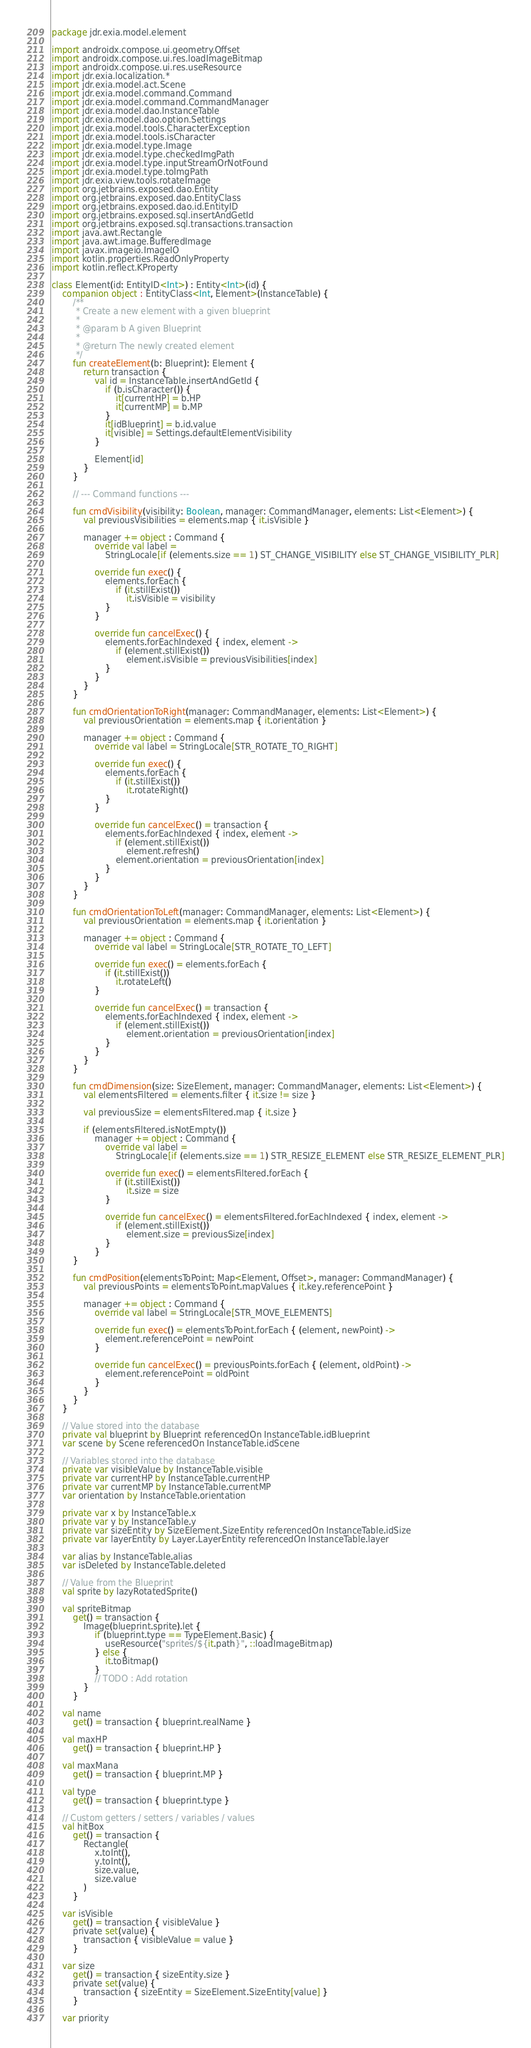<code> <loc_0><loc_0><loc_500><loc_500><_Kotlin_>package jdr.exia.model.element

import androidx.compose.ui.geometry.Offset
import androidx.compose.ui.res.loadImageBitmap
import androidx.compose.ui.res.useResource
import jdr.exia.localization.*
import jdr.exia.model.act.Scene
import jdr.exia.model.command.Command
import jdr.exia.model.command.CommandManager
import jdr.exia.model.dao.InstanceTable
import jdr.exia.model.dao.option.Settings
import jdr.exia.model.tools.CharacterException
import jdr.exia.model.tools.isCharacter
import jdr.exia.model.type.Image
import jdr.exia.model.type.checkedImgPath
import jdr.exia.model.type.inputStreamOrNotFound
import jdr.exia.model.type.toImgPath
import jdr.exia.view.tools.rotateImage
import org.jetbrains.exposed.dao.Entity
import org.jetbrains.exposed.dao.EntityClass
import org.jetbrains.exposed.dao.id.EntityID
import org.jetbrains.exposed.sql.insertAndGetId
import org.jetbrains.exposed.sql.transactions.transaction
import java.awt.Rectangle
import java.awt.image.BufferedImage
import javax.imageio.ImageIO
import kotlin.properties.ReadOnlyProperty
import kotlin.reflect.KProperty

class Element(id: EntityID<Int>) : Entity<Int>(id) {
    companion object : EntityClass<Int, Element>(InstanceTable) {
        /**
         * Create a new element with a given blueprint
         *
         * @param b A given Blueprint
         *
         * @return The newly created element
         */
        fun createElement(b: Blueprint): Element {
            return transaction {
                val id = InstanceTable.insertAndGetId {
                    if (b.isCharacter()) {
                        it[currentHP] = b.HP
                        it[currentMP] = b.MP
                    }
                    it[idBlueprint] = b.id.value
                    it[visible] = Settings.defaultElementVisibility
                }

                Element[id]
            }
        }

        // --- Command functions ---

        fun cmdVisibility(visibility: Boolean, manager: CommandManager, elements: List<Element>) {
            val previousVisibilities = elements.map { it.isVisible }

            manager += object : Command {
                override val label =
                    StringLocale[if (elements.size == 1) ST_CHANGE_VISIBILITY else ST_CHANGE_VISIBILITY_PLR]

                override fun exec() {
                    elements.forEach {
                        if (it.stillExist())
                            it.isVisible = visibility
                    }
                }

                override fun cancelExec() {
                    elements.forEachIndexed { index, element ->
                        if (element.stillExist())
                            element.isVisible = previousVisibilities[index]
                    }
                }
            }
        }

        fun cmdOrientationToRight(manager: CommandManager, elements: List<Element>) {
            val previousOrientation = elements.map { it.orientation }

            manager += object : Command {
                override val label = StringLocale[STR_ROTATE_TO_RIGHT]

                override fun exec() {
                    elements.forEach {
                        if (it.stillExist())
                            it.rotateRight()
                    }
                }

                override fun cancelExec() = transaction {
                    elements.forEachIndexed { index, element ->
                        if (element.stillExist())
                            element.refresh()
                        element.orientation = previousOrientation[index]
                    }
                }
            }
        }

        fun cmdOrientationToLeft(manager: CommandManager, elements: List<Element>) {
            val previousOrientation = elements.map { it.orientation }

            manager += object : Command {
                override val label = StringLocale[STR_ROTATE_TO_LEFT]

                override fun exec() = elements.forEach {
                    if (it.stillExist())
                        it.rotateLeft()
                }

                override fun cancelExec() = transaction {
                    elements.forEachIndexed { index, element ->
                        if (element.stillExist())
                            element.orientation = previousOrientation[index]
                    }
                }
            }
        }

        fun cmdDimension(size: SizeElement, manager: CommandManager, elements: List<Element>) {
            val elementsFiltered = elements.filter { it.size != size }

            val previousSize = elementsFiltered.map { it.size }

            if (elementsFiltered.isNotEmpty())
                manager += object : Command {
                    override val label =
                        StringLocale[if (elements.size == 1) STR_RESIZE_ELEMENT else STR_RESIZE_ELEMENT_PLR]

                    override fun exec() = elementsFiltered.forEach {
                        if (it.stillExist())
                            it.size = size
                    }

                    override fun cancelExec() = elementsFiltered.forEachIndexed { index, element ->
                        if (element.stillExist())
                            element.size = previousSize[index]
                    }
                }
        }

        fun cmdPosition(elementsToPoint: Map<Element, Offset>, manager: CommandManager) {
            val previousPoints = elementsToPoint.mapValues { it.key.referencePoint }

            manager += object : Command {
                override val label = StringLocale[STR_MOVE_ELEMENTS]

                override fun exec() = elementsToPoint.forEach { (element, newPoint) ->
                    element.referencePoint = newPoint
                }

                override fun cancelExec() = previousPoints.forEach { (element, oldPoint) ->
                    element.referencePoint = oldPoint
                }
            }
        }
    }

    // Value stored into the database
    private val blueprint by Blueprint referencedOn InstanceTable.idBlueprint
    var scene by Scene referencedOn InstanceTable.idScene

    // Variables stored into the database
    private var visibleValue by InstanceTable.visible
    private var currentHP by InstanceTable.currentHP
    private var currentMP by InstanceTable.currentMP
    var orientation by InstanceTable.orientation

    private var x by InstanceTable.x
    private var y by InstanceTable.y
    private var sizeEntity by SizeElement.SizeEntity referencedOn InstanceTable.idSize
    private var layerEntity by Layer.LayerEntity referencedOn InstanceTable.layer

    var alias by InstanceTable.alias
    var isDeleted by InstanceTable.deleted

    // Value from the Blueprint
    val sprite by lazyRotatedSprite()

    val spriteBitmap
        get() = transaction {
            Image(blueprint.sprite).let {
                if (blueprint.type == TypeElement.Basic) {
                    useResource("sprites/${it.path}", ::loadImageBitmap)
                } else {
                    it.toBitmap()
                }
                // TODO : Add rotation
            }
        }

    val name
        get() = transaction { blueprint.realName }

    val maxHP
        get() = transaction { blueprint.HP }

    val maxMana
        get() = transaction { blueprint.MP }

    val type
        get() = transaction { blueprint.type }

    // Custom getters / setters / variables / values
    val hitBox
        get() = transaction {
            Rectangle(
                x.toInt(),
                y.toInt(),
                size.value,
                size.value
            )
        }

    var isVisible
        get() = transaction { visibleValue }
        private set(value) {
            transaction { visibleValue = value }
        }

    var size
        get() = transaction { sizeEntity.size }
        private set(value) {
            transaction { sizeEntity = SizeElement.SizeEntity[value] }
        }

    var priority</code> 